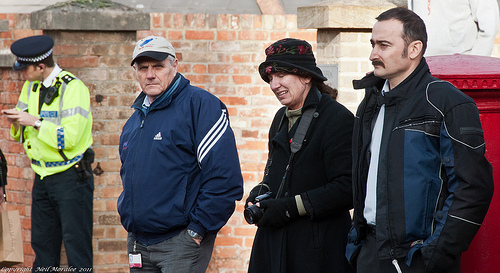<image>
Can you confirm if the man is on the camera? No. The man is not positioned on the camera. They may be near each other, but the man is not supported by or resting on top of the camera. 